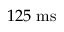Convert formula to latex. <formula><loc_0><loc_0><loc_500><loc_500>1 2 5 m s</formula> 